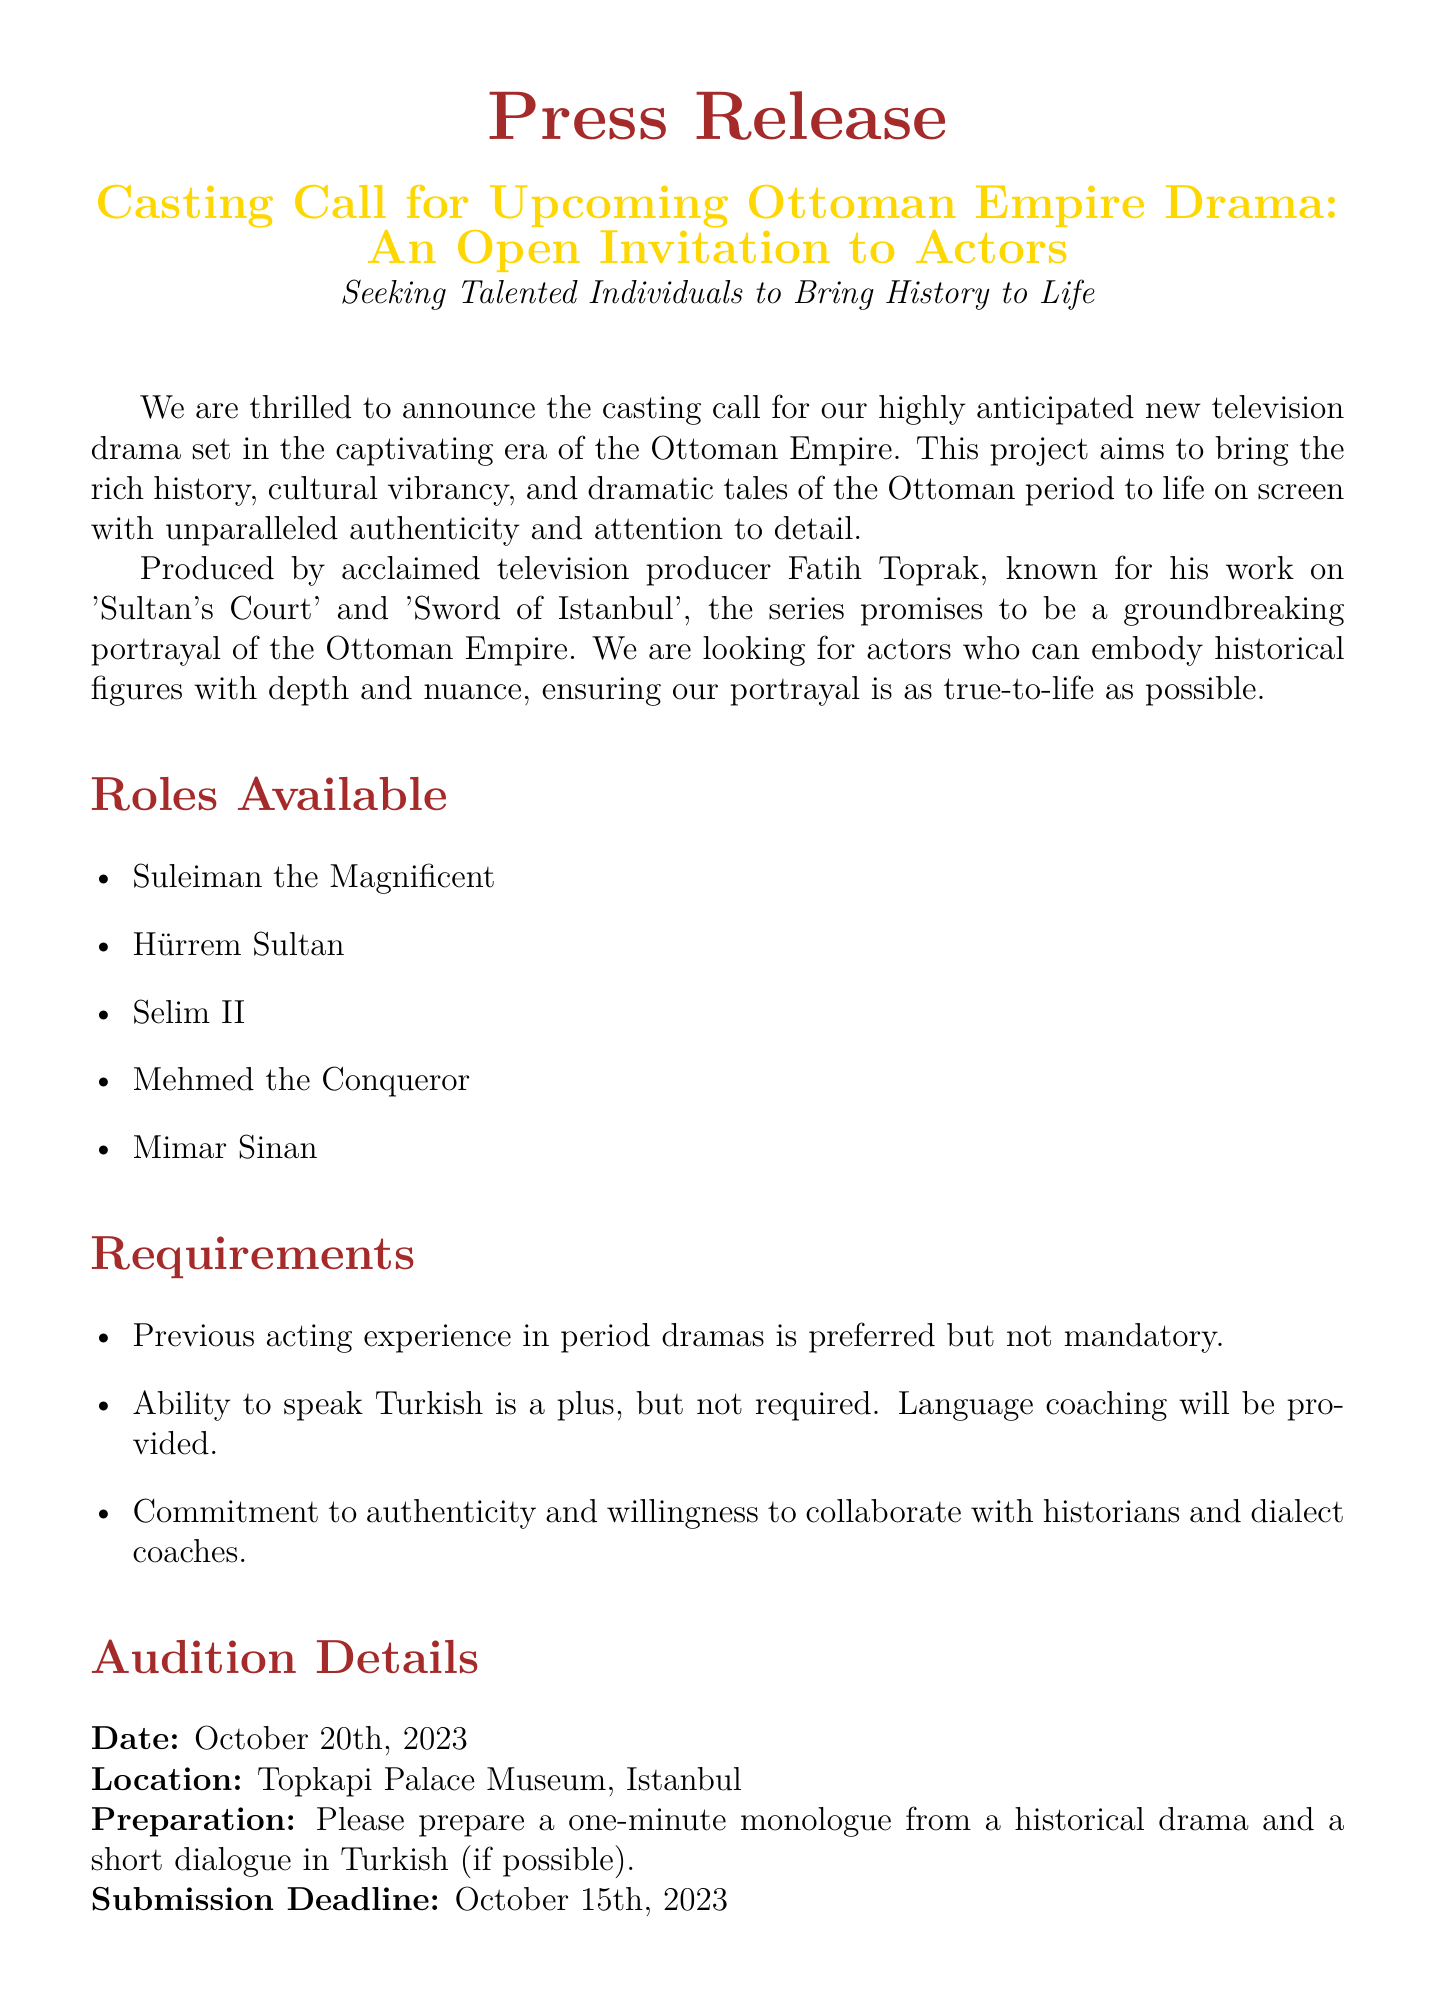What is the title of the drama? The title is specified in the document as "Casting Call for Upcoming Ottoman Empire Drama: An Open Invitation to Actors".
Answer: Upcoming Ottoman Empire Drama Who is the producer of the series? The document mentions that the producer is Fatih Toprak.
Answer: Fatih Toprak What roles are mentioned in the casting call? The document lists specific roles such as Suleiman the Magnificent, Hürrem Sultan, Selim II, Mehmed the Conqueror, and Mimar Sinan.
Answer: Suleiman the Magnificent, Hürrem Sultan, Selim II, Mehmed the Conqueror, Mimar Sinan When is the audition date? The audition date is explicitly stated in the document as October 20th, 2023.
Answer: October 20th, 2023 What is the preparation requirement for auditions? The document specifies that actors should prepare a one-minute monologue from a historical drama and a short dialogue in Turkish.
Answer: One-minute monologue; short dialogue in Turkish Is previous acting experience required? The document indicates that previous acting experience is preferred but not mandatory.
Answer: Preferred but not mandatory What is the submission deadline for auditions? The submission deadline is explicitly mentioned as October 15th, 2023.
Answer: October 15th, 2023 What language skill is mentioned in the requirements? The document notes that the ability to speak Turkish is a plus, but not required.
Answer: Speak Turkish 